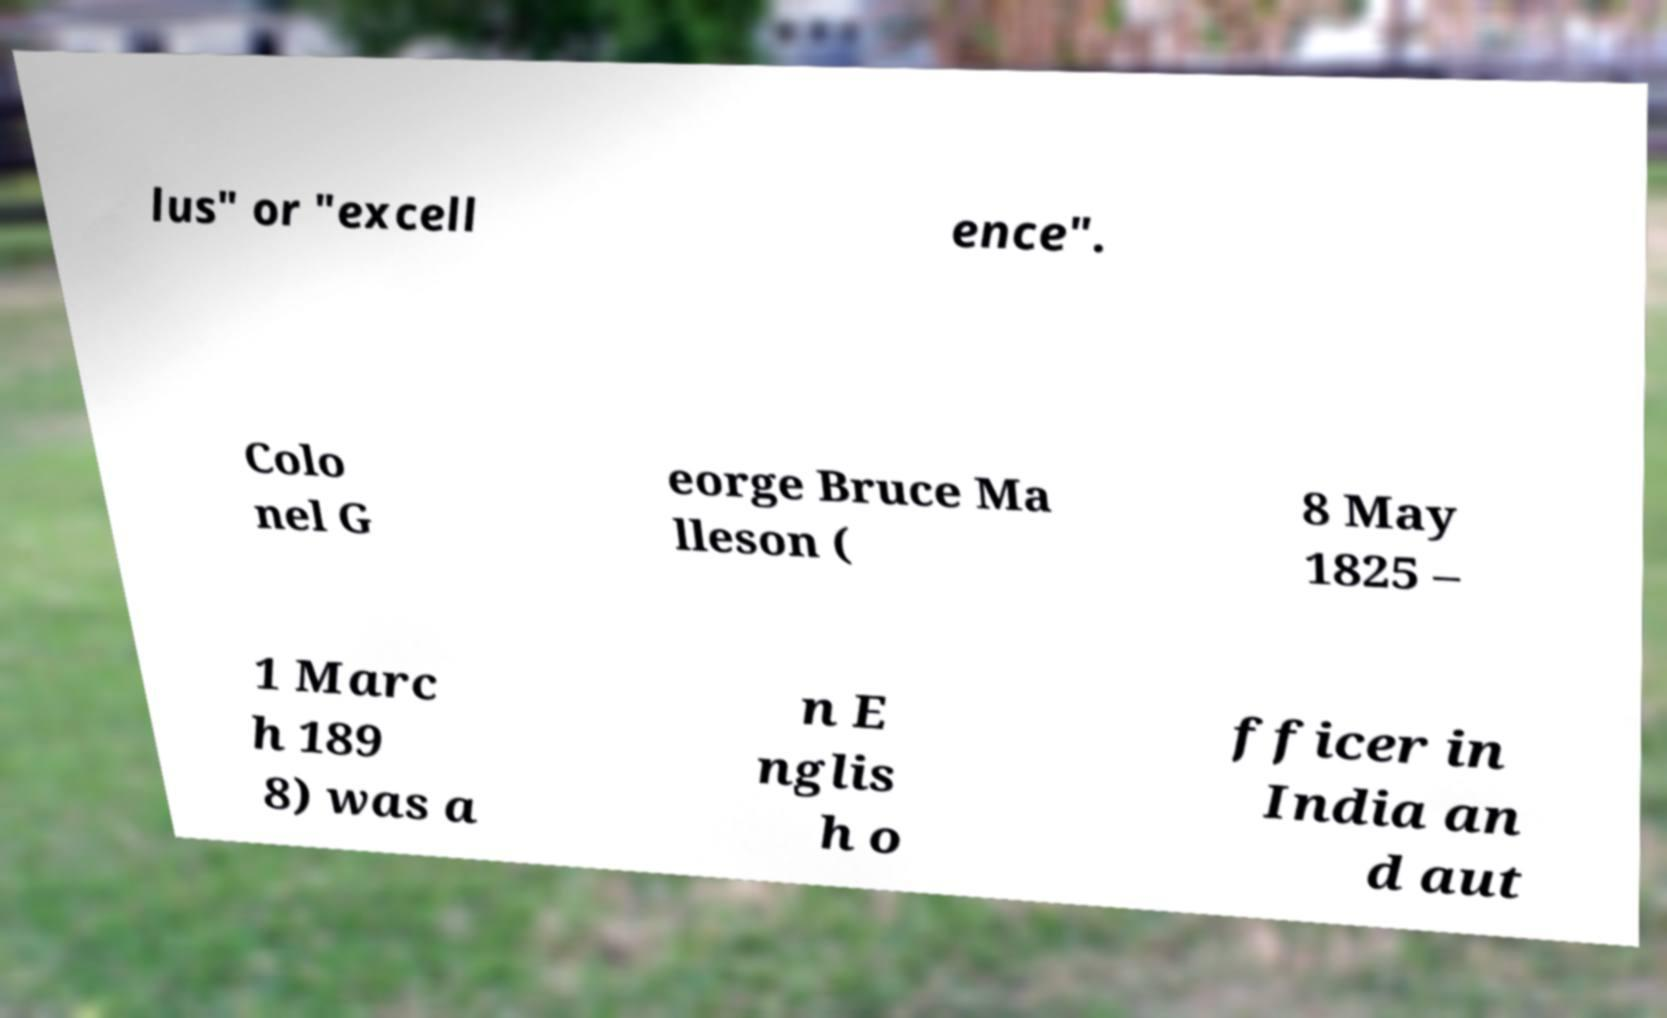Can you read and provide the text displayed in the image?This photo seems to have some interesting text. Can you extract and type it out for me? lus" or "excell ence". Colo nel G eorge Bruce Ma lleson ( 8 May 1825 – 1 Marc h 189 8) was a n E nglis h o fficer in India an d aut 